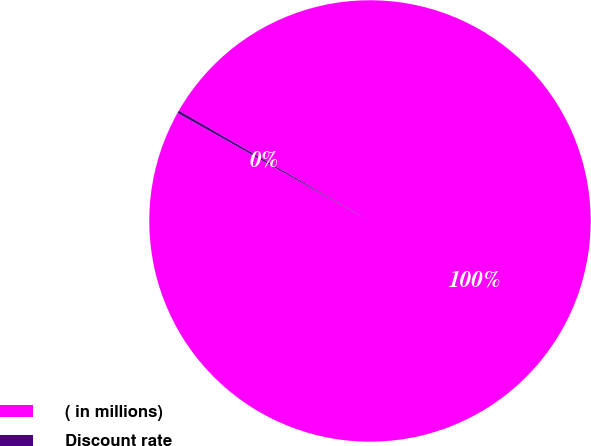Convert chart. <chart><loc_0><loc_0><loc_500><loc_500><pie_chart><fcel>( in millions)<fcel>Discount rate<nl><fcel>99.8%<fcel>0.2%<nl></chart> 